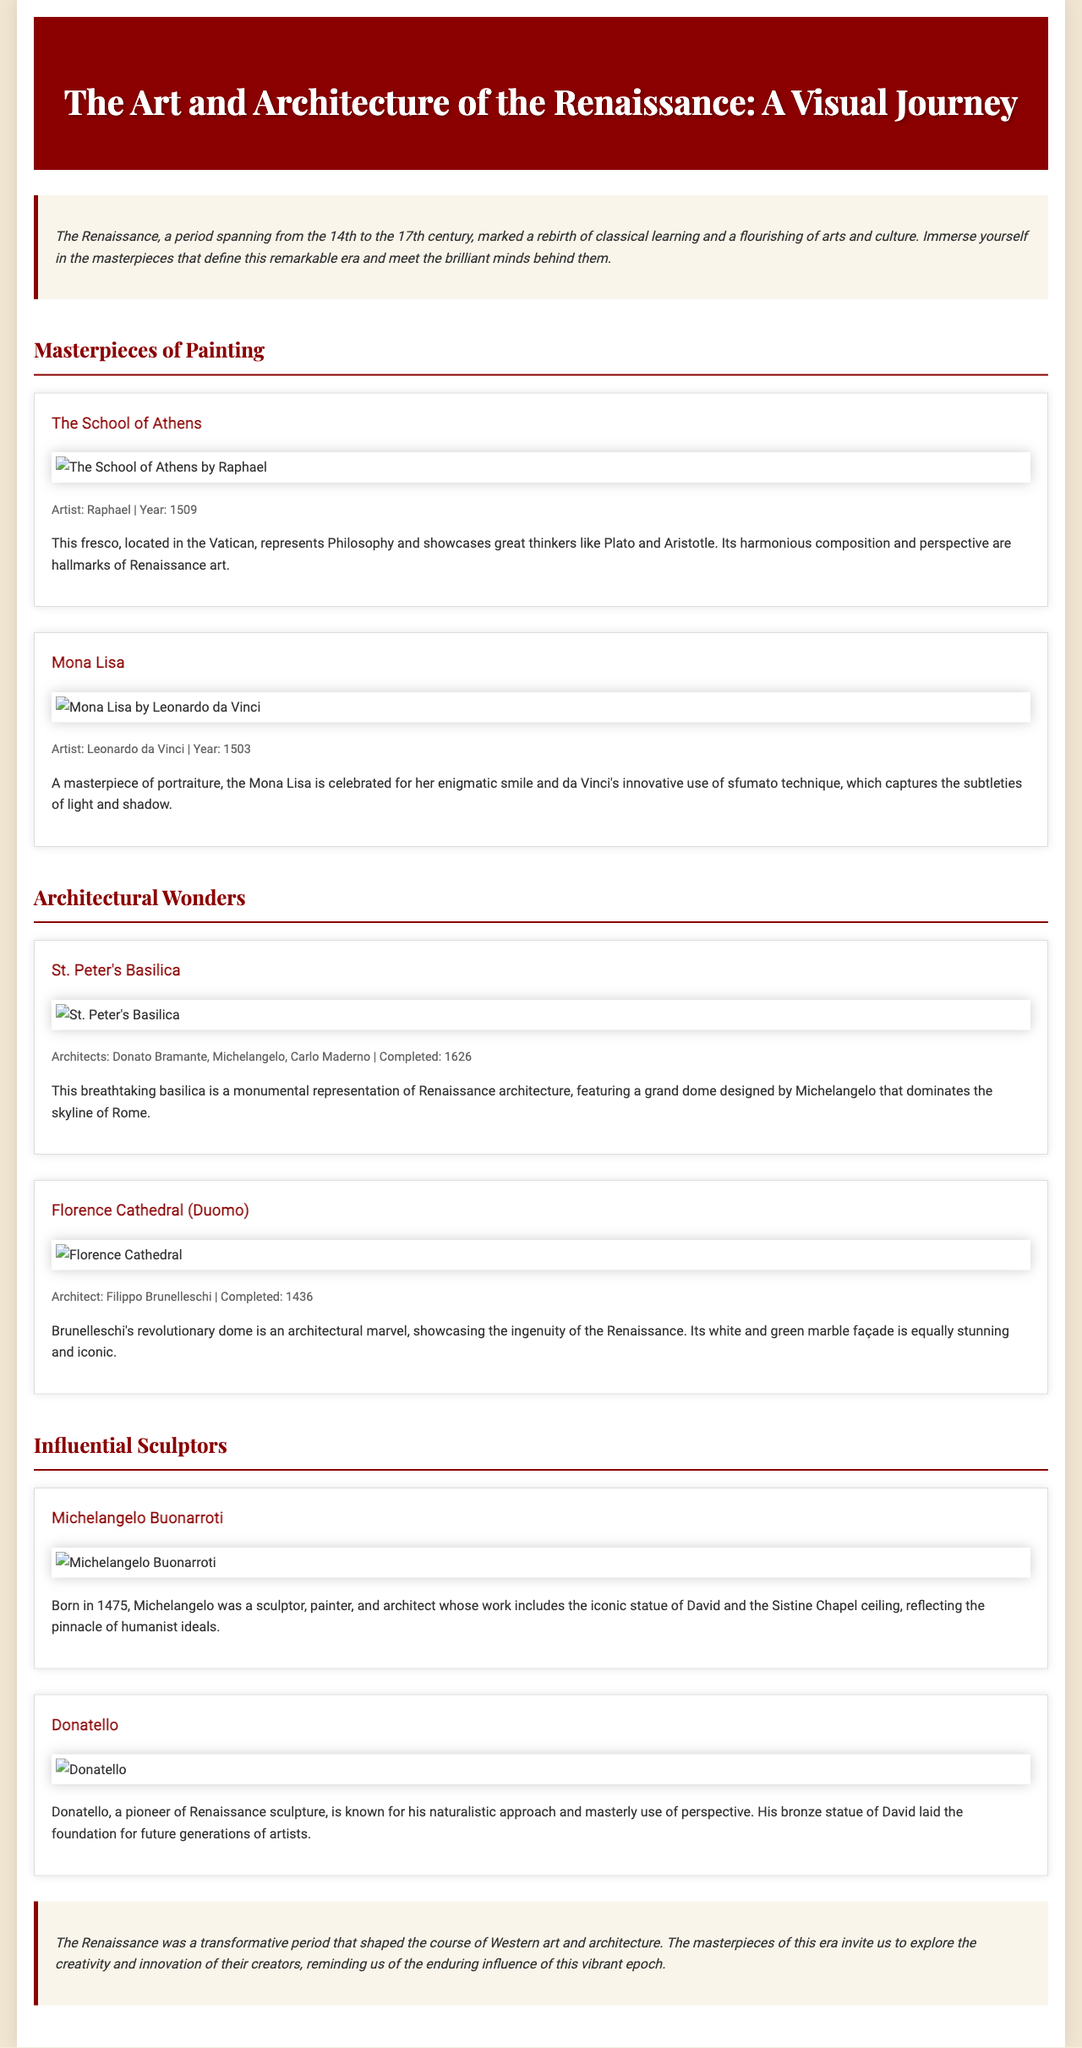What is the time period of the Renaissance? The document states that the Renaissance spans from the 14th to the 17th century.
Answer: 14th to 17th century Who painted the Mona Lisa? The artist of the Mona Lisa, as mentioned in the document, is Leonardo da Vinci.
Answer: Leonardo da Vinci What year was The School of Athens completed? The document indicates that The School of Athens was completed in the year 1509.
Answer: 1509 Which church features a dome designed by Michelangelo? The text refers to St. Peter's Basilica, which features a dome designed by Michelangelo.
Answer: St. Peter's Basilica What material is Donatello's famous statue of David made of? The document describes Donatello's David as a bronze statue, highlighting his material choice.
Answer: Bronze What is a distinctive technique used in the Mona Lisa? The document mentions that Leonardo da Vinci used the sfumato technique for the Mona Lisa.
Answer: Sfumato Which architect is credited with the completion of the Florence Cathedral? Filippo Brunelleschi is identified in the document as the architect who completed the Florence Cathedral.
Answer: Filippo Brunelleschi How is the layout of The Art and Architecture of the Renaissance structured? The document is organized into sections about paintings, architecture, and sculptors, guiding the reader through different artistic forms.
Answer: Sections: paintings, architecture, sculptors 